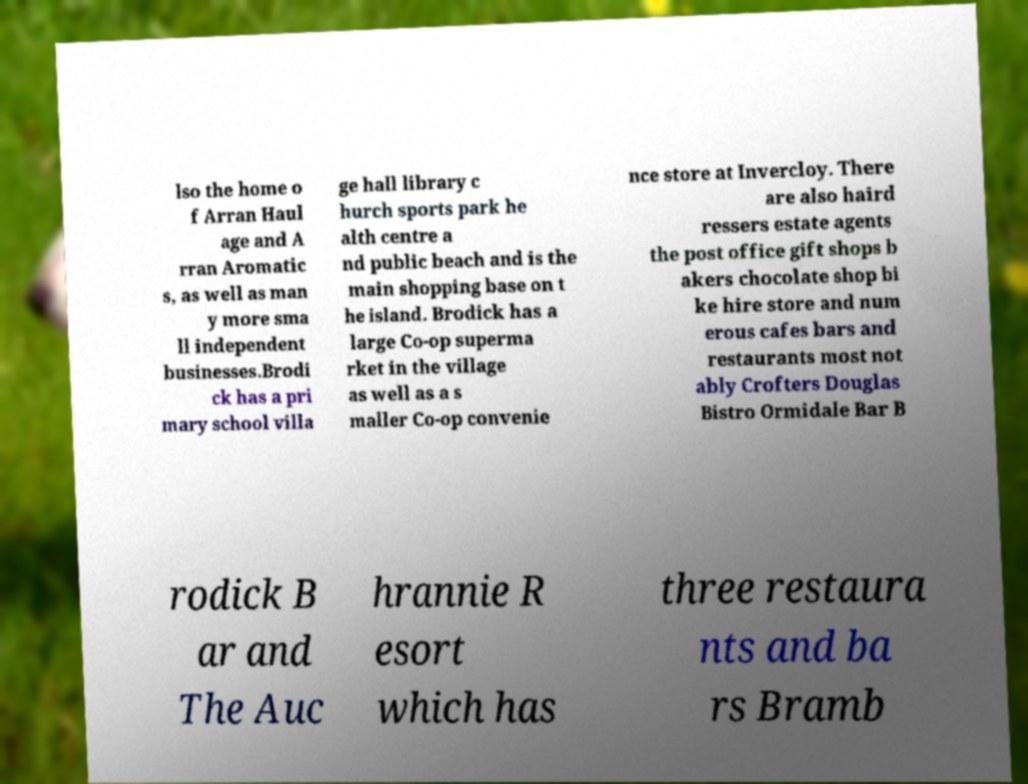Please read and relay the text visible in this image. What does it say? lso the home o f Arran Haul age and A rran Aromatic s, as well as man y more sma ll independent businesses.Brodi ck has a pri mary school villa ge hall library c hurch sports park he alth centre a nd public beach and is the main shopping base on t he island. Brodick has a large Co-op superma rket in the village as well as a s maller Co-op convenie nce store at Invercloy. There are also haird ressers estate agents the post office gift shops b akers chocolate shop bi ke hire store and num erous cafes bars and restaurants most not ably Crofters Douglas Bistro Ormidale Bar B rodick B ar and The Auc hrannie R esort which has three restaura nts and ba rs Bramb 